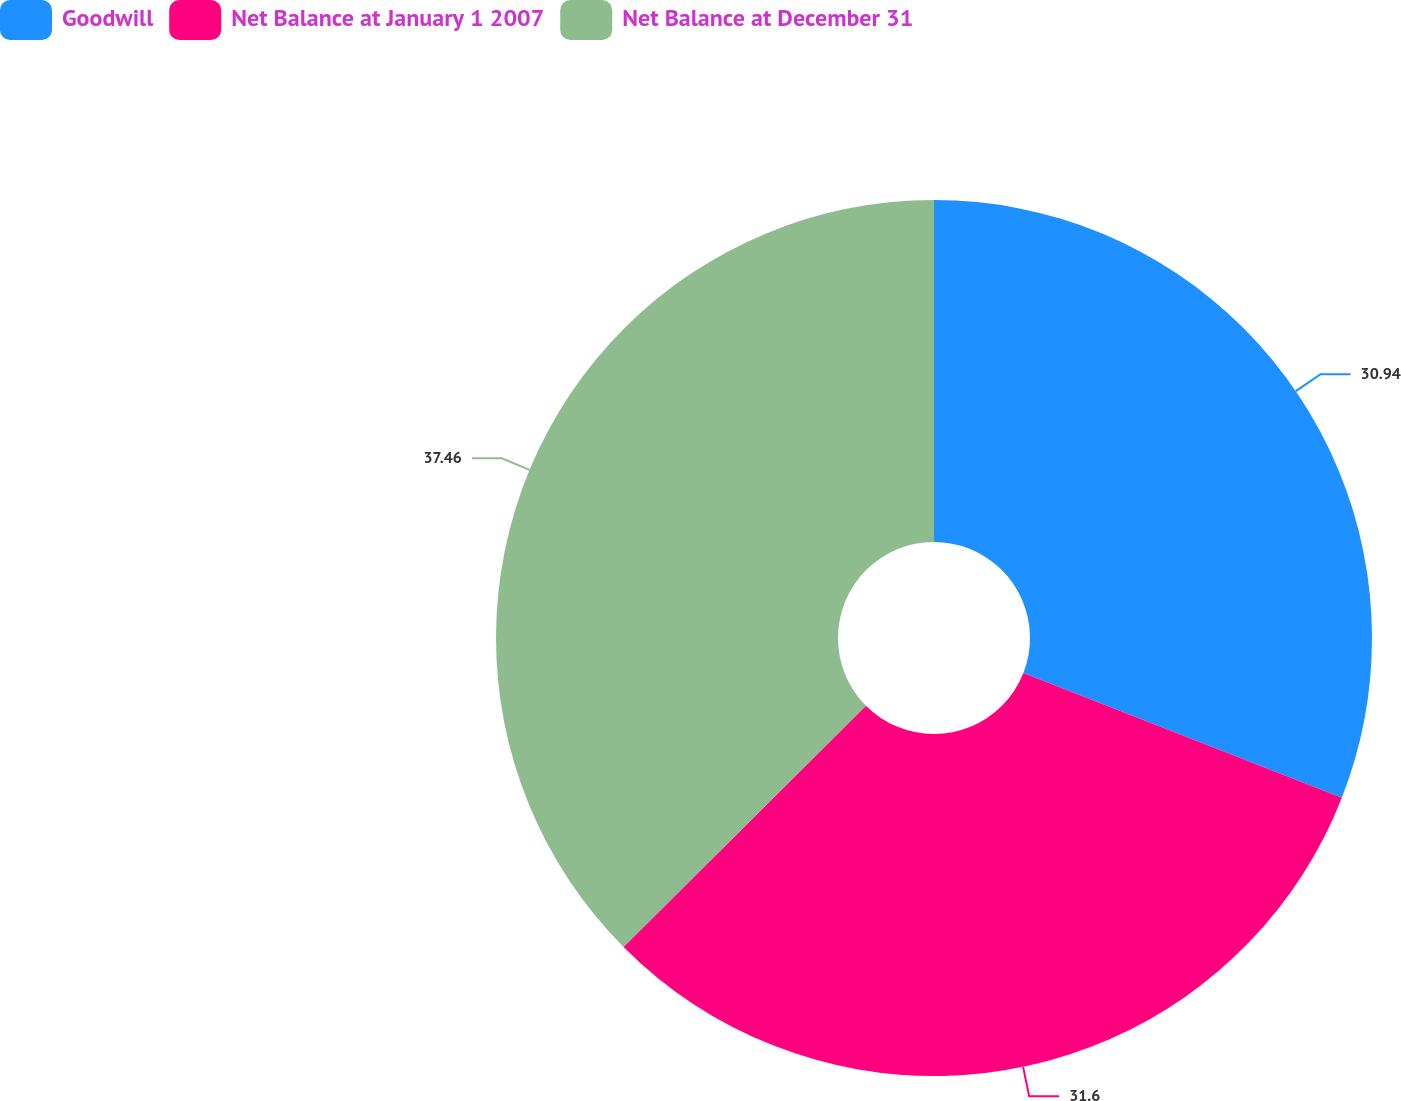Convert chart to OTSL. <chart><loc_0><loc_0><loc_500><loc_500><pie_chart><fcel>Goodwill<fcel>Net Balance at January 1 2007<fcel>Net Balance at December 31<nl><fcel>30.94%<fcel>31.6%<fcel>37.46%<nl></chart> 